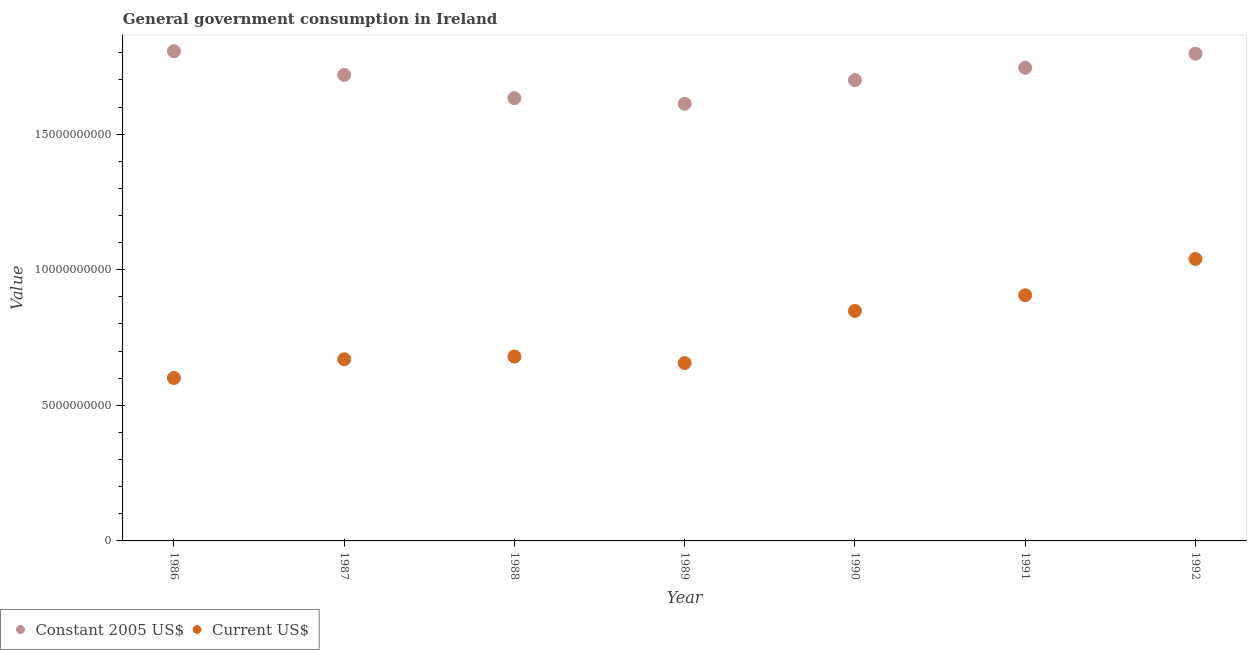Is the number of dotlines equal to the number of legend labels?
Your answer should be compact. Yes. What is the value consumed in current us$ in 1987?
Your answer should be compact. 6.70e+09. Across all years, what is the maximum value consumed in constant 2005 us$?
Ensure brevity in your answer.  1.81e+1. Across all years, what is the minimum value consumed in current us$?
Provide a short and direct response. 6.01e+09. In which year was the value consumed in current us$ minimum?
Your answer should be compact. 1986. What is the total value consumed in constant 2005 us$ in the graph?
Your answer should be very brief. 1.20e+11. What is the difference between the value consumed in current us$ in 1987 and that in 1991?
Offer a very short reply. -2.36e+09. What is the difference between the value consumed in constant 2005 us$ in 1989 and the value consumed in current us$ in 1992?
Offer a very short reply. 5.72e+09. What is the average value consumed in current us$ per year?
Provide a succinct answer. 7.71e+09. In the year 1986, what is the difference between the value consumed in constant 2005 us$ and value consumed in current us$?
Your response must be concise. 1.20e+1. In how many years, is the value consumed in constant 2005 us$ greater than 7000000000?
Give a very brief answer. 7. What is the ratio of the value consumed in constant 2005 us$ in 1989 to that in 1992?
Keep it short and to the point. 0.9. Is the value consumed in current us$ in 1987 less than that in 1992?
Give a very brief answer. Yes. Is the difference between the value consumed in current us$ in 1986 and 1990 greater than the difference between the value consumed in constant 2005 us$ in 1986 and 1990?
Make the answer very short. No. What is the difference between the highest and the second highest value consumed in constant 2005 us$?
Provide a succinct answer. 9.11e+07. What is the difference between the highest and the lowest value consumed in current us$?
Give a very brief answer. 4.39e+09. Does the value consumed in constant 2005 us$ monotonically increase over the years?
Give a very brief answer. No. Is the value consumed in current us$ strictly greater than the value consumed in constant 2005 us$ over the years?
Provide a succinct answer. No. Is the value consumed in constant 2005 us$ strictly less than the value consumed in current us$ over the years?
Offer a very short reply. No. How many dotlines are there?
Your answer should be very brief. 2. What is the difference between two consecutive major ticks on the Y-axis?
Provide a succinct answer. 5.00e+09. Does the graph contain grids?
Give a very brief answer. No. Where does the legend appear in the graph?
Your response must be concise. Bottom left. How are the legend labels stacked?
Keep it short and to the point. Horizontal. What is the title of the graph?
Keep it short and to the point. General government consumption in Ireland. Does "Under-5(male)" appear as one of the legend labels in the graph?
Provide a short and direct response. No. What is the label or title of the X-axis?
Give a very brief answer. Year. What is the label or title of the Y-axis?
Provide a succinct answer. Value. What is the Value of Constant 2005 US$ in 1986?
Provide a succinct answer. 1.81e+1. What is the Value in Current US$ in 1986?
Your answer should be very brief. 6.01e+09. What is the Value of Constant 2005 US$ in 1987?
Offer a terse response. 1.72e+1. What is the Value of Current US$ in 1987?
Give a very brief answer. 6.70e+09. What is the Value in Constant 2005 US$ in 1988?
Give a very brief answer. 1.63e+1. What is the Value in Current US$ in 1988?
Keep it short and to the point. 6.80e+09. What is the Value of Constant 2005 US$ in 1989?
Provide a short and direct response. 1.61e+1. What is the Value in Current US$ in 1989?
Your answer should be very brief. 6.56e+09. What is the Value in Constant 2005 US$ in 1990?
Provide a short and direct response. 1.70e+1. What is the Value in Current US$ in 1990?
Give a very brief answer. 8.48e+09. What is the Value in Constant 2005 US$ in 1991?
Ensure brevity in your answer.  1.74e+1. What is the Value in Current US$ in 1991?
Offer a very short reply. 9.06e+09. What is the Value of Constant 2005 US$ in 1992?
Provide a succinct answer. 1.80e+1. What is the Value of Current US$ in 1992?
Provide a succinct answer. 1.04e+1. Across all years, what is the maximum Value of Constant 2005 US$?
Keep it short and to the point. 1.81e+1. Across all years, what is the maximum Value of Current US$?
Offer a very short reply. 1.04e+1. Across all years, what is the minimum Value of Constant 2005 US$?
Your answer should be very brief. 1.61e+1. Across all years, what is the minimum Value of Current US$?
Provide a short and direct response. 6.01e+09. What is the total Value of Constant 2005 US$ in the graph?
Offer a very short reply. 1.20e+11. What is the total Value of Current US$ in the graph?
Ensure brevity in your answer.  5.40e+1. What is the difference between the Value in Constant 2005 US$ in 1986 and that in 1987?
Offer a very short reply. 8.75e+08. What is the difference between the Value in Current US$ in 1986 and that in 1987?
Offer a very short reply. -6.89e+08. What is the difference between the Value in Constant 2005 US$ in 1986 and that in 1988?
Keep it short and to the point. 1.73e+09. What is the difference between the Value of Current US$ in 1986 and that in 1988?
Make the answer very short. -7.89e+08. What is the difference between the Value in Constant 2005 US$ in 1986 and that in 1989?
Your answer should be compact. 1.94e+09. What is the difference between the Value of Current US$ in 1986 and that in 1989?
Provide a short and direct response. -5.49e+08. What is the difference between the Value of Constant 2005 US$ in 1986 and that in 1990?
Offer a terse response. 1.07e+09. What is the difference between the Value of Current US$ in 1986 and that in 1990?
Your answer should be compact. -2.47e+09. What is the difference between the Value in Constant 2005 US$ in 1986 and that in 1991?
Provide a succinct answer. 6.09e+08. What is the difference between the Value of Current US$ in 1986 and that in 1991?
Your answer should be compact. -3.05e+09. What is the difference between the Value of Constant 2005 US$ in 1986 and that in 1992?
Keep it short and to the point. 9.11e+07. What is the difference between the Value in Current US$ in 1986 and that in 1992?
Your response must be concise. -4.39e+09. What is the difference between the Value of Constant 2005 US$ in 1987 and that in 1988?
Your response must be concise. 8.56e+08. What is the difference between the Value in Current US$ in 1987 and that in 1988?
Ensure brevity in your answer.  -1.00e+08. What is the difference between the Value of Constant 2005 US$ in 1987 and that in 1989?
Provide a short and direct response. 1.06e+09. What is the difference between the Value of Current US$ in 1987 and that in 1989?
Provide a short and direct response. 1.40e+08. What is the difference between the Value in Constant 2005 US$ in 1987 and that in 1990?
Provide a short and direct response. 1.90e+08. What is the difference between the Value in Current US$ in 1987 and that in 1990?
Keep it short and to the point. -1.78e+09. What is the difference between the Value in Constant 2005 US$ in 1987 and that in 1991?
Offer a very short reply. -2.66e+08. What is the difference between the Value of Current US$ in 1987 and that in 1991?
Give a very brief answer. -2.36e+09. What is the difference between the Value in Constant 2005 US$ in 1987 and that in 1992?
Provide a succinct answer. -7.84e+08. What is the difference between the Value of Current US$ in 1987 and that in 1992?
Ensure brevity in your answer.  -3.70e+09. What is the difference between the Value of Constant 2005 US$ in 1988 and that in 1989?
Your response must be concise. 2.08e+08. What is the difference between the Value in Current US$ in 1988 and that in 1989?
Offer a very short reply. 2.40e+08. What is the difference between the Value in Constant 2005 US$ in 1988 and that in 1990?
Offer a very short reply. -6.66e+08. What is the difference between the Value of Current US$ in 1988 and that in 1990?
Your response must be concise. -1.68e+09. What is the difference between the Value in Constant 2005 US$ in 1988 and that in 1991?
Give a very brief answer. -1.12e+09. What is the difference between the Value of Current US$ in 1988 and that in 1991?
Your answer should be compact. -2.26e+09. What is the difference between the Value in Constant 2005 US$ in 1988 and that in 1992?
Offer a very short reply. -1.64e+09. What is the difference between the Value in Current US$ in 1988 and that in 1992?
Your response must be concise. -3.60e+09. What is the difference between the Value of Constant 2005 US$ in 1989 and that in 1990?
Give a very brief answer. -8.74e+08. What is the difference between the Value in Current US$ in 1989 and that in 1990?
Your response must be concise. -1.92e+09. What is the difference between the Value in Constant 2005 US$ in 1989 and that in 1991?
Your answer should be compact. -1.33e+09. What is the difference between the Value of Current US$ in 1989 and that in 1991?
Provide a succinct answer. -2.50e+09. What is the difference between the Value of Constant 2005 US$ in 1989 and that in 1992?
Offer a terse response. -1.85e+09. What is the difference between the Value in Current US$ in 1989 and that in 1992?
Your answer should be compact. -3.84e+09. What is the difference between the Value in Constant 2005 US$ in 1990 and that in 1991?
Provide a succinct answer. -4.56e+08. What is the difference between the Value in Current US$ in 1990 and that in 1991?
Your response must be concise. -5.78e+08. What is the difference between the Value in Constant 2005 US$ in 1990 and that in 1992?
Ensure brevity in your answer.  -9.74e+08. What is the difference between the Value of Current US$ in 1990 and that in 1992?
Your answer should be compact. -1.92e+09. What is the difference between the Value of Constant 2005 US$ in 1991 and that in 1992?
Provide a succinct answer. -5.18e+08. What is the difference between the Value in Current US$ in 1991 and that in 1992?
Give a very brief answer. -1.34e+09. What is the difference between the Value of Constant 2005 US$ in 1986 and the Value of Current US$ in 1987?
Your answer should be very brief. 1.14e+1. What is the difference between the Value of Constant 2005 US$ in 1986 and the Value of Current US$ in 1988?
Your answer should be very brief. 1.13e+1. What is the difference between the Value of Constant 2005 US$ in 1986 and the Value of Current US$ in 1989?
Keep it short and to the point. 1.15e+1. What is the difference between the Value in Constant 2005 US$ in 1986 and the Value in Current US$ in 1990?
Ensure brevity in your answer.  9.58e+09. What is the difference between the Value in Constant 2005 US$ in 1986 and the Value in Current US$ in 1991?
Provide a succinct answer. 9.00e+09. What is the difference between the Value of Constant 2005 US$ in 1986 and the Value of Current US$ in 1992?
Give a very brief answer. 7.66e+09. What is the difference between the Value in Constant 2005 US$ in 1987 and the Value in Current US$ in 1988?
Offer a terse response. 1.04e+1. What is the difference between the Value of Constant 2005 US$ in 1987 and the Value of Current US$ in 1989?
Offer a very short reply. 1.06e+1. What is the difference between the Value in Constant 2005 US$ in 1987 and the Value in Current US$ in 1990?
Your response must be concise. 8.70e+09. What is the difference between the Value in Constant 2005 US$ in 1987 and the Value in Current US$ in 1991?
Keep it short and to the point. 8.12e+09. What is the difference between the Value in Constant 2005 US$ in 1987 and the Value in Current US$ in 1992?
Your response must be concise. 6.79e+09. What is the difference between the Value in Constant 2005 US$ in 1988 and the Value in Current US$ in 1989?
Offer a very short reply. 9.77e+09. What is the difference between the Value in Constant 2005 US$ in 1988 and the Value in Current US$ in 1990?
Make the answer very short. 7.85e+09. What is the difference between the Value in Constant 2005 US$ in 1988 and the Value in Current US$ in 1991?
Your response must be concise. 7.27e+09. What is the difference between the Value of Constant 2005 US$ in 1988 and the Value of Current US$ in 1992?
Your answer should be compact. 5.93e+09. What is the difference between the Value of Constant 2005 US$ in 1989 and the Value of Current US$ in 1990?
Your answer should be compact. 7.64e+09. What is the difference between the Value in Constant 2005 US$ in 1989 and the Value in Current US$ in 1991?
Keep it short and to the point. 7.06e+09. What is the difference between the Value in Constant 2005 US$ in 1989 and the Value in Current US$ in 1992?
Make the answer very short. 5.72e+09. What is the difference between the Value in Constant 2005 US$ in 1990 and the Value in Current US$ in 1991?
Make the answer very short. 7.93e+09. What is the difference between the Value of Constant 2005 US$ in 1990 and the Value of Current US$ in 1992?
Offer a very short reply. 6.60e+09. What is the difference between the Value in Constant 2005 US$ in 1991 and the Value in Current US$ in 1992?
Ensure brevity in your answer.  7.05e+09. What is the average Value of Constant 2005 US$ per year?
Provide a short and direct response. 1.72e+1. What is the average Value in Current US$ per year?
Offer a very short reply. 7.71e+09. In the year 1986, what is the difference between the Value of Constant 2005 US$ and Value of Current US$?
Give a very brief answer. 1.20e+1. In the year 1987, what is the difference between the Value of Constant 2005 US$ and Value of Current US$?
Your answer should be compact. 1.05e+1. In the year 1988, what is the difference between the Value of Constant 2005 US$ and Value of Current US$?
Offer a very short reply. 9.53e+09. In the year 1989, what is the difference between the Value in Constant 2005 US$ and Value in Current US$?
Offer a very short reply. 9.56e+09. In the year 1990, what is the difference between the Value in Constant 2005 US$ and Value in Current US$?
Ensure brevity in your answer.  8.51e+09. In the year 1991, what is the difference between the Value of Constant 2005 US$ and Value of Current US$?
Keep it short and to the point. 8.39e+09. In the year 1992, what is the difference between the Value in Constant 2005 US$ and Value in Current US$?
Provide a short and direct response. 7.57e+09. What is the ratio of the Value in Constant 2005 US$ in 1986 to that in 1987?
Your answer should be very brief. 1.05. What is the ratio of the Value in Current US$ in 1986 to that in 1987?
Make the answer very short. 0.9. What is the ratio of the Value of Constant 2005 US$ in 1986 to that in 1988?
Provide a short and direct response. 1.11. What is the ratio of the Value of Current US$ in 1986 to that in 1988?
Provide a succinct answer. 0.88. What is the ratio of the Value of Constant 2005 US$ in 1986 to that in 1989?
Provide a succinct answer. 1.12. What is the ratio of the Value in Current US$ in 1986 to that in 1989?
Give a very brief answer. 0.92. What is the ratio of the Value of Constant 2005 US$ in 1986 to that in 1990?
Your response must be concise. 1.06. What is the ratio of the Value in Current US$ in 1986 to that in 1990?
Provide a succinct answer. 0.71. What is the ratio of the Value in Constant 2005 US$ in 1986 to that in 1991?
Provide a succinct answer. 1.03. What is the ratio of the Value in Current US$ in 1986 to that in 1991?
Keep it short and to the point. 0.66. What is the ratio of the Value in Current US$ in 1986 to that in 1992?
Make the answer very short. 0.58. What is the ratio of the Value in Constant 2005 US$ in 1987 to that in 1988?
Ensure brevity in your answer.  1.05. What is the ratio of the Value of Current US$ in 1987 to that in 1988?
Make the answer very short. 0.99. What is the ratio of the Value in Constant 2005 US$ in 1987 to that in 1989?
Ensure brevity in your answer.  1.07. What is the ratio of the Value in Current US$ in 1987 to that in 1989?
Offer a very short reply. 1.02. What is the ratio of the Value in Constant 2005 US$ in 1987 to that in 1990?
Give a very brief answer. 1.01. What is the ratio of the Value of Current US$ in 1987 to that in 1990?
Offer a very short reply. 0.79. What is the ratio of the Value in Constant 2005 US$ in 1987 to that in 1991?
Offer a very short reply. 0.98. What is the ratio of the Value of Current US$ in 1987 to that in 1991?
Your response must be concise. 0.74. What is the ratio of the Value of Constant 2005 US$ in 1987 to that in 1992?
Offer a very short reply. 0.96. What is the ratio of the Value of Current US$ in 1987 to that in 1992?
Ensure brevity in your answer.  0.64. What is the ratio of the Value of Constant 2005 US$ in 1988 to that in 1989?
Your answer should be compact. 1.01. What is the ratio of the Value of Current US$ in 1988 to that in 1989?
Offer a terse response. 1.04. What is the ratio of the Value in Constant 2005 US$ in 1988 to that in 1990?
Ensure brevity in your answer.  0.96. What is the ratio of the Value of Current US$ in 1988 to that in 1990?
Your answer should be very brief. 0.8. What is the ratio of the Value in Constant 2005 US$ in 1988 to that in 1991?
Provide a short and direct response. 0.94. What is the ratio of the Value of Current US$ in 1988 to that in 1991?
Ensure brevity in your answer.  0.75. What is the ratio of the Value of Constant 2005 US$ in 1988 to that in 1992?
Provide a succinct answer. 0.91. What is the ratio of the Value of Current US$ in 1988 to that in 1992?
Give a very brief answer. 0.65. What is the ratio of the Value of Constant 2005 US$ in 1989 to that in 1990?
Ensure brevity in your answer.  0.95. What is the ratio of the Value in Current US$ in 1989 to that in 1990?
Offer a terse response. 0.77. What is the ratio of the Value of Constant 2005 US$ in 1989 to that in 1991?
Make the answer very short. 0.92. What is the ratio of the Value of Current US$ in 1989 to that in 1991?
Provide a succinct answer. 0.72. What is the ratio of the Value of Constant 2005 US$ in 1989 to that in 1992?
Make the answer very short. 0.9. What is the ratio of the Value of Current US$ in 1989 to that in 1992?
Provide a short and direct response. 0.63. What is the ratio of the Value of Constant 2005 US$ in 1990 to that in 1991?
Offer a very short reply. 0.97. What is the ratio of the Value in Current US$ in 1990 to that in 1991?
Your response must be concise. 0.94. What is the ratio of the Value of Constant 2005 US$ in 1990 to that in 1992?
Offer a very short reply. 0.95. What is the ratio of the Value of Current US$ in 1990 to that in 1992?
Provide a succinct answer. 0.82. What is the ratio of the Value of Constant 2005 US$ in 1991 to that in 1992?
Make the answer very short. 0.97. What is the ratio of the Value in Current US$ in 1991 to that in 1992?
Provide a succinct answer. 0.87. What is the difference between the highest and the second highest Value in Constant 2005 US$?
Ensure brevity in your answer.  9.11e+07. What is the difference between the highest and the second highest Value of Current US$?
Your answer should be compact. 1.34e+09. What is the difference between the highest and the lowest Value of Constant 2005 US$?
Make the answer very short. 1.94e+09. What is the difference between the highest and the lowest Value in Current US$?
Your answer should be very brief. 4.39e+09. 